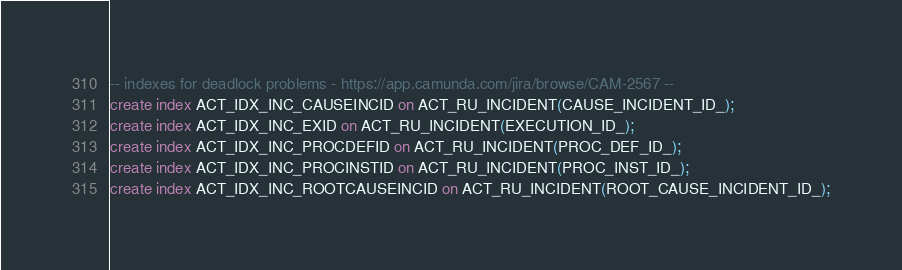Convert code to text. <code><loc_0><loc_0><loc_500><loc_500><_SQL_>-- indexes for deadlock problems - https://app.camunda.com/jira/browse/CAM-2567 --
create index ACT_IDX_INC_CAUSEINCID on ACT_RU_INCIDENT(CAUSE_INCIDENT_ID_);
create index ACT_IDX_INC_EXID on ACT_RU_INCIDENT(EXECUTION_ID_);
create index ACT_IDX_INC_PROCDEFID on ACT_RU_INCIDENT(PROC_DEF_ID_);
create index ACT_IDX_INC_PROCINSTID on ACT_RU_INCIDENT(PROC_INST_ID_);
create index ACT_IDX_INC_ROOTCAUSEINCID on ACT_RU_INCIDENT(ROOT_CAUSE_INCIDENT_ID_);
</code> 